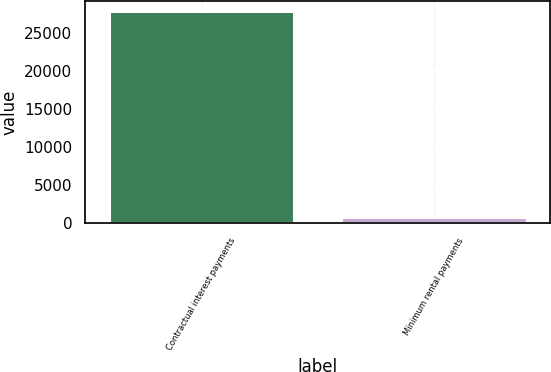<chart> <loc_0><loc_0><loc_500><loc_500><bar_chart><fcel>Contractual interest payments<fcel>Minimum rental payments<nl><fcel>27915<fcel>771<nl></chart> 